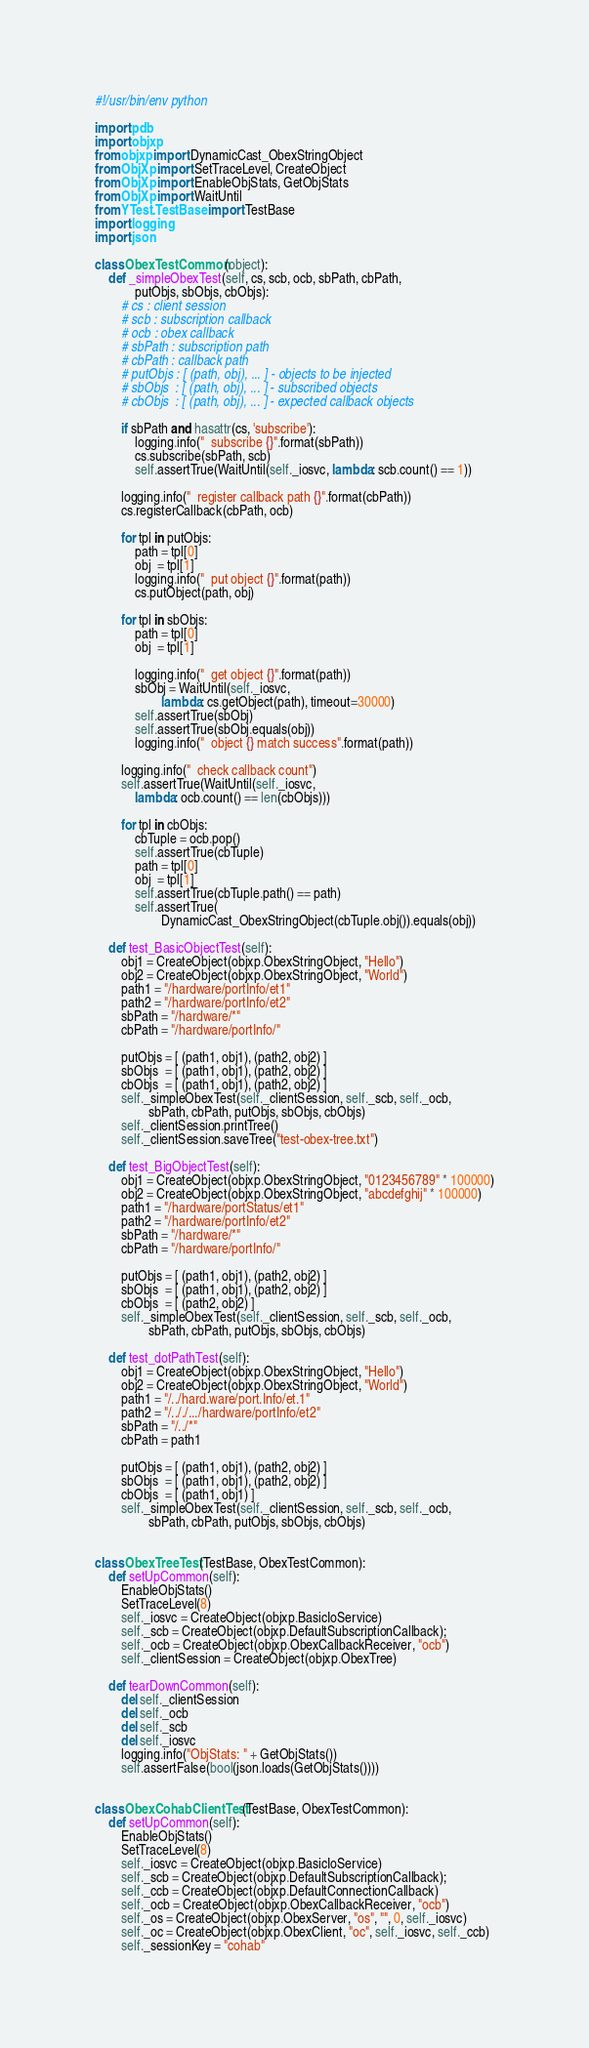Convert code to text. <code><loc_0><loc_0><loc_500><loc_500><_Python_>#!/usr/bin/env python

import pdb
import objxp
from objxp import DynamicCast_ObexStringObject
from ObjXp import SetTraceLevel, CreateObject
from ObjXp import EnableObjStats, GetObjStats
from ObjXp import WaitUntil
from YTest.TestBase import TestBase
import logging
import json

class ObexTestCommon(object):
    def _simpleObexTest(self, cs, scb, ocb, sbPath, cbPath,
            putObjs, sbObjs, cbObjs):
        # cs : client session
        # scb : subscription callback
        # ocb : obex callback
        # sbPath : subscription path
        # cbPath : callback path
        # putObjs : [ (path, obj), ... ] - objects to be injected
        # sbObjs  : [ (path, obj), ... ] - subscribed objects
        # cbObjs  : [ (path, obj), ... ] - expected callback objects

        if sbPath and hasattr(cs, 'subscribe'):
            logging.info("  subscribe {}".format(sbPath))
            cs.subscribe(sbPath, scb)
            self.assertTrue(WaitUntil(self._iosvc, lambda: scb.count() == 1))

        logging.info("  register callback path {}".format(cbPath))
        cs.registerCallback(cbPath, ocb)

        for tpl in putObjs:
            path = tpl[0]
            obj  = tpl[1]
            logging.info("  put object {}".format(path))
            cs.putObject(path, obj)

        for tpl in sbObjs:
            path = tpl[0]
            obj  = tpl[1]

            logging.info("  get object {}".format(path))
            sbObj = WaitUntil(self._iosvc,
                    lambda: cs.getObject(path), timeout=30000)
            self.assertTrue(sbObj)
            self.assertTrue(sbObj.equals(obj))
            logging.info("  object {} match success".format(path))

        logging.info("  check callback count")
        self.assertTrue(WaitUntil(self._iosvc,
            lambda: ocb.count() == len(cbObjs)))

        for tpl in cbObjs:
            cbTuple = ocb.pop()
            self.assertTrue(cbTuple)
            path = tpl[0]
            obj  = tpl[1]
            self.assertTrue(cbTuple.path() == path)
            self.assertTrue(
                    DynamicCast_ObexStringObject(cbTuple.obj()).equals(obj))

    def test_BasicObjectTest(self):
        obj1 = CreateObject(objxp.ObexStringObject, "Hello")
        obj2 = CreateObject(objxp.ObexStringObject, "World")
        path1 = "/hardware/portInfo/et1"
        path2 = "/hardware/portInfo/et2"
        sbPath = "/hardware/*"
        cbPath = "/hardware/portInfo/"

        putObjs = [ (path1, obj1), (path2, obj2) ]
        sbObjs  = [ (path1, obj1), (path2, obj2) ]
        cbObjs  = [ (path1, obj1), (path2, obj2) ]
        self._simpleObexTest(self._clientSession, self._scb, self._ocb,
                sbPath, cbPath, putObjs, sbObjs, cbObjs)
        self._clientSession.printTree()
        self._clientSession.saveTree("test-obex-tree.txt")

    def test_BigObjectTest(self):
        obj1 = CreateObject(objxp.ObexStringObject, "0123456789" * 100000)
        obj2 = CreateObject(objxp.ObexStringObject, "abcdefghij" * 100000)
        path1 = "/hardware/portStatus/et1"
        path2 = "/hardware/portInfo/et2"
        sbPath = "/hardware/*"
        cbPath = "/hardware/portInfo/"

        putObjs = [ (path1, obj1), (path2, obj2) ]
        sbObjs  = [ (path1, obj1), (path2, obj2) ]
        cbObjs  = [ (path2, obj2) ]
        self._simpleObexTest(self._clientSession, self._scb, self._ocb,
                sbPath, cbPath, putObjs, sbObjs, cbObjs)

    def test_dotPathTest(self):
        obj1 = CreateObject(objxp.ObexStringObject, "Hello")
        obj2 = CreateObject(objxp.ObexStringObject, "World")
        path1 = "/../hard.ware/port.Info/et.1"
        path2 = "/.././.../hardware/portInfo/et2"
        sbPath = "/../*"
        cbPath = path1

        putObjs = [ (path1, obj1), (path2, obj2) ]
        sbObjs  = [ (path1, obj1), (path2, obj2) ]
        cbObjs  = [ (path1, obj1) ]
        self._simpleObexTest(self._clientSession, self._scb, self._ocb,
                sbPath, cbPath, putObjs, sbObjs, cbObjs)


class ObexTreeTest(TestBase, ObexTestCommon):
    def setUpCommon(self):
        EnableObjStats()
        SetTraceLevel(8)
        self._iosvc = CreateObject(objxp.BasicIoService)
        self._scb = CreateObject(objxp.DefaultSubscriptionCallback);
        self._ocb = CreateObject(objxp.ObexCallbackReceiver, "ocb")
        self._clientSession = CreateObject(objxp.ObexTree)

    def tearDownCommon(self):
        del self._clientSession
        del self._ocb
        del self._scb
        del self._iosvc
        logging.info("ObjStats: " + GetObjStats())
        self.assertFalse(bool(json.loads(GetObjStats())))


class ObexCohabClientTest(TestBase, ObexTestCommon):
    def setUpCommon(self):
        EnableObjStats()
        SetTraceLevel(8)
        self._iosvc = CreateObject(objxp.BasicIoService)
        self._scb = CreateObject(objxp.DefaultSubscriptionCallback);
        self._ccb = CreateObject(objxp.DefaultConnectionCallback)
        self._ocb = CreateObject(objxp.ObexCallbackReceiver, "ocb")
        self._os = CreateObject(objxp.ObexServer, "os", "", 0, self._iosvc)
        self._oc = CreateObject(objxp.ObexClient, "oc", self._iosvc, self._ccb)
        self._sessionKey = "cohab"</code> 